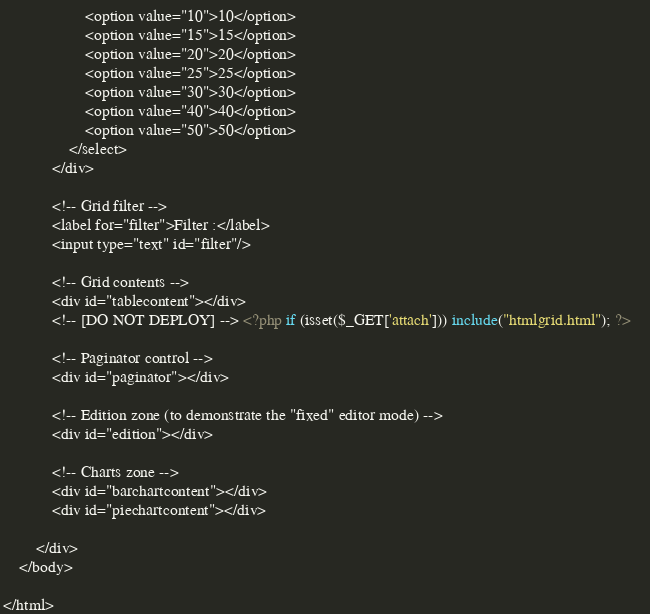Convert code to text. <code><loc_0><loc_0><loc_500><loc_500><_PHP_>					<option value="10">10</option>
					<option value="15">15</option>
					<option value="20">20</option>
					<option value="25">25</option>
					<option value="30">30</option>
					<option value="40">40</option>
					<option value="50">50</option>
				</select>	
			</div>
		
			<!-- Grid filter -->
			<label for="filter">Filter :</label>
			<input type="text" id="filter"/>
		
			<!-- Grid contents -->
			<div id="tablecontent"></div>
			<!-- [DO NOT DEPLOY] --> <?php if (isset($_GET['attach'])) include("htmlgrid.html"); ?>	
		
			<!-- Paginator control -->
			<div id="paginator"></div>
		
			<!-- Edition zone (to demonstrate the "fixed" editor mode) -->
			<div id="edition"></div>
			
			<!-- Charts zone -->
			<div id="barchartcontent"></div>
			<div id="piechartcontent"></div>
			
		</div>
	</body>

</html>
</code> 